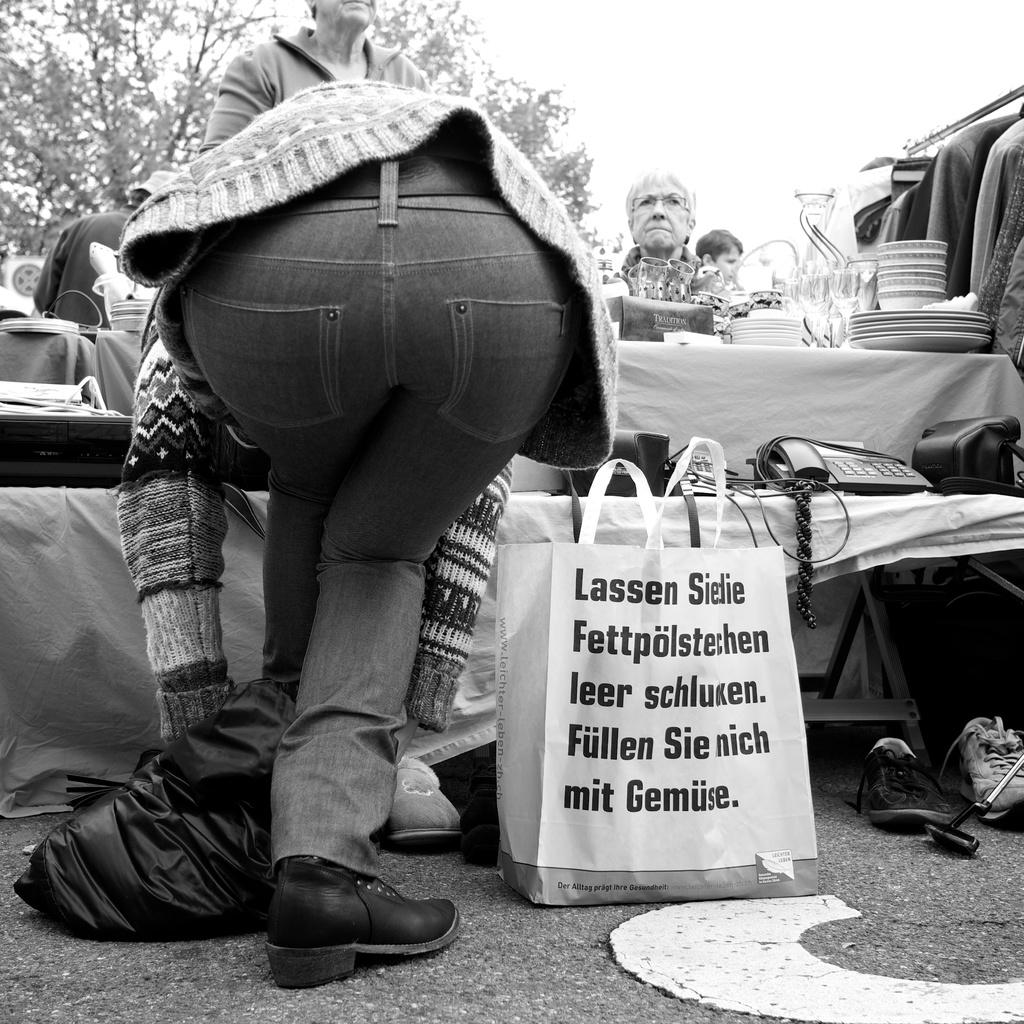<image>
Offer a succinct explanation of the picture presented. A resuable bag with Lassen written on it. 